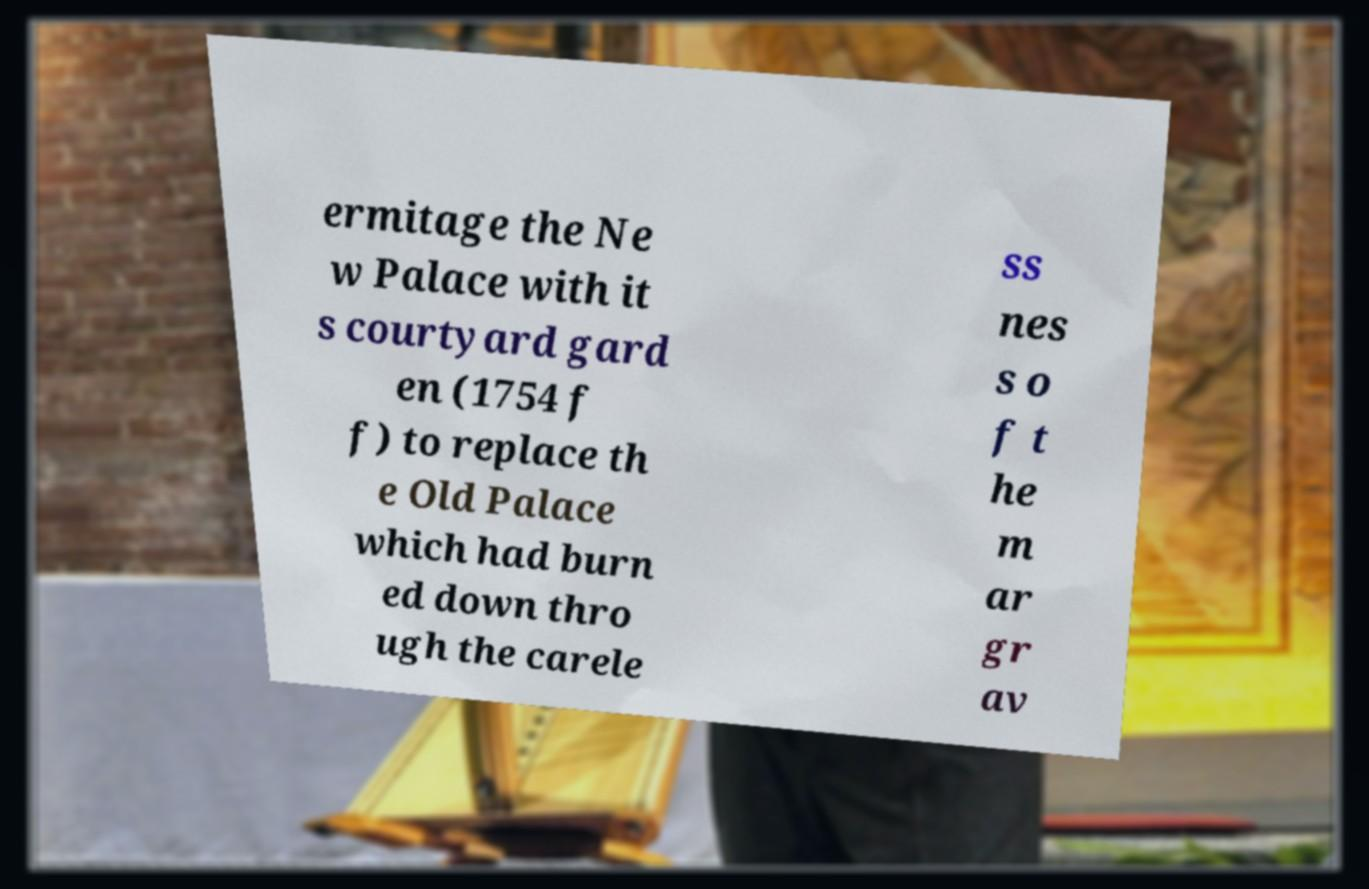What messages or text are displayed in this image? I need them in a readable, typed format. ermitage the Ne w Palace with it s courtyard gard en (1754 f f) to replace th e Old Palace which had burn ed down thro ugh the carele ss nes s o f t he m ar gr av 